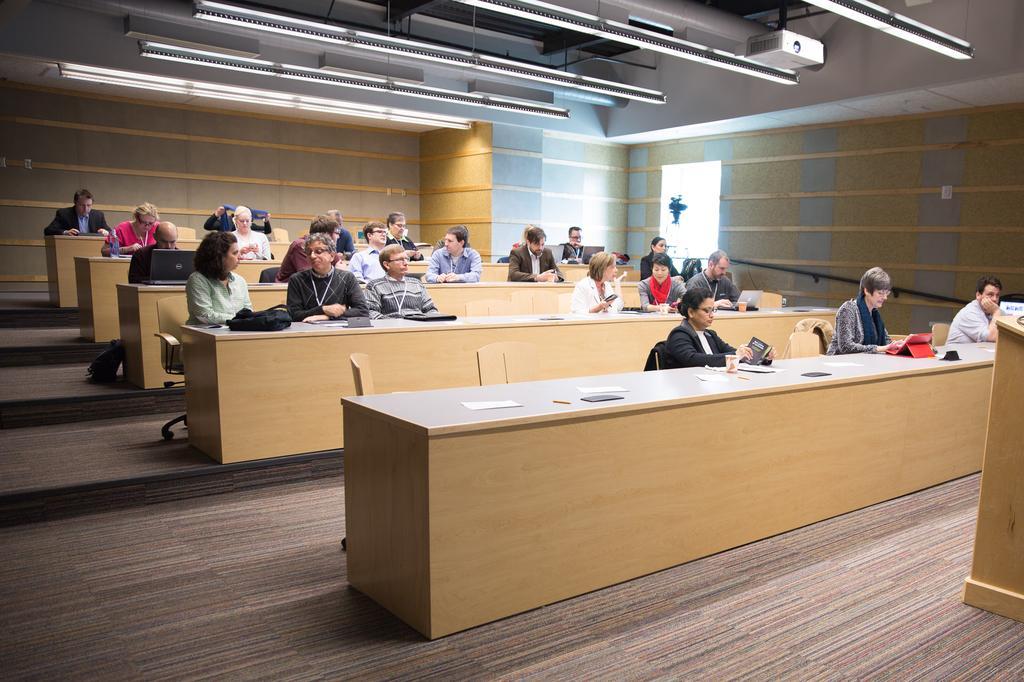Could you give a brief overview of what you see in this image? This image is taken in a room. In the room there are some tables, chairs and some people are sitting on them. On the floor there is a mat. In the right side there is a podium. In the top there are some lights. 